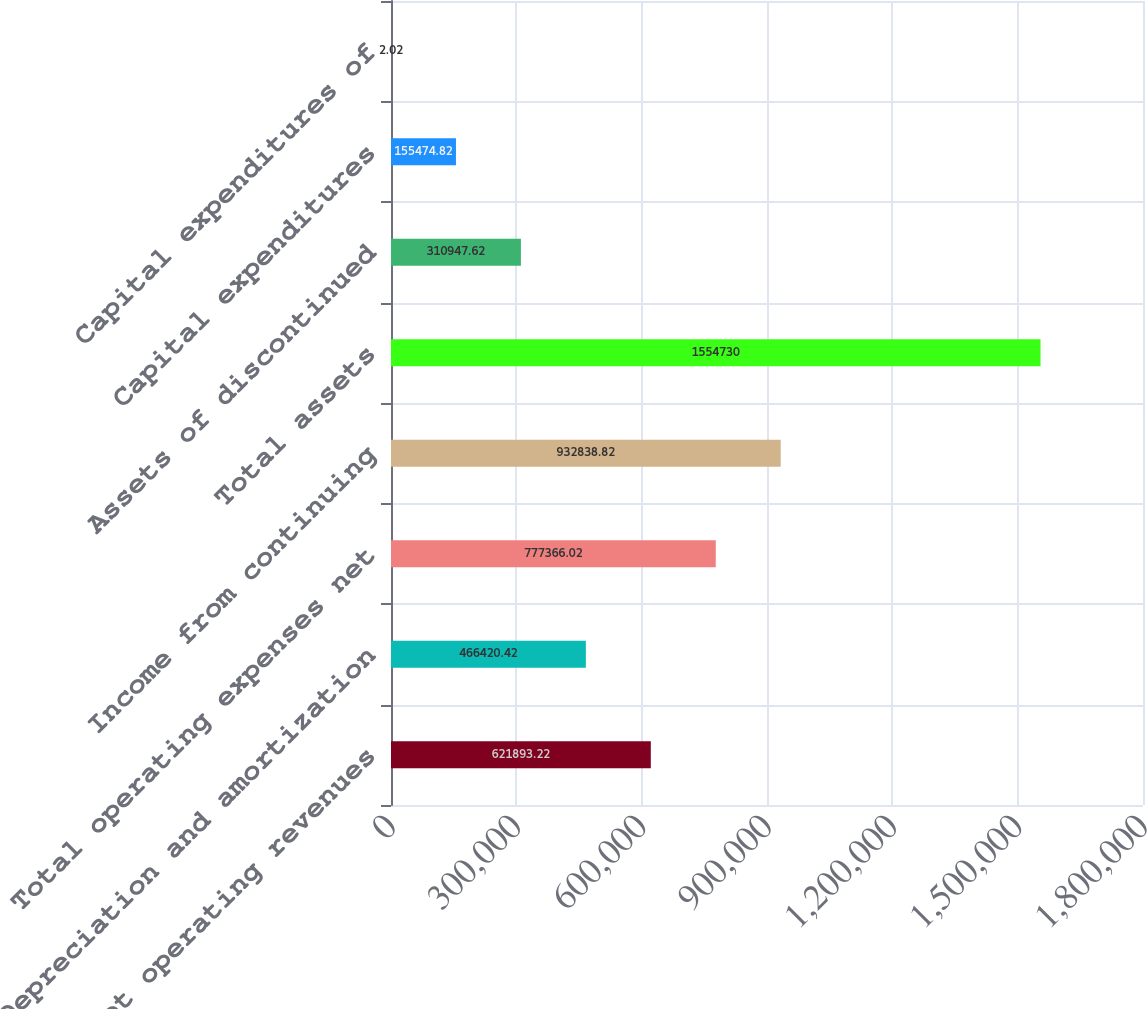<chart> <loc_0><loc_0><loc_500><loc_500><bar_chart><fcel>Net operating revenues<fcel>Depreciation and amortization<fcel>Total operating expenses net<fcel>Income from continuing<fcel>Total assets<fcel>Assets of discontinued<fcel>Capital expenditures<fcel>Capital expenditures of<nl><fcel>621893<fcel>466420<fcel>777366<fcel>932839<fcel>1.55473e+06<fcel>310948<fcel>155475<fcel>2.02<nl></chart> 